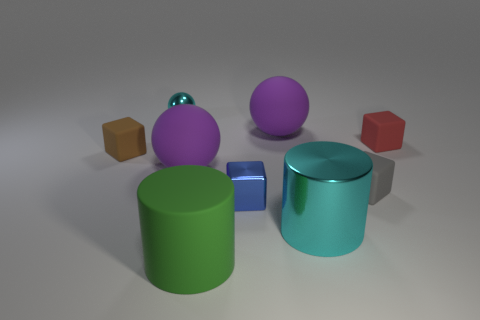Add 1 large red metallic cylinders. How many objects exist? 10 Subtract all cubes. How many objects are left? 5 Add 2 cylinders. How many cylinders are left? 4 Add 4 purple spheres. How many purple spheres exist? 6 Subtract 0 cyan blocks. How many objects are left? 9 Subtract all brown blocks. Subtract all small gray balls. How many objects are left? 8 